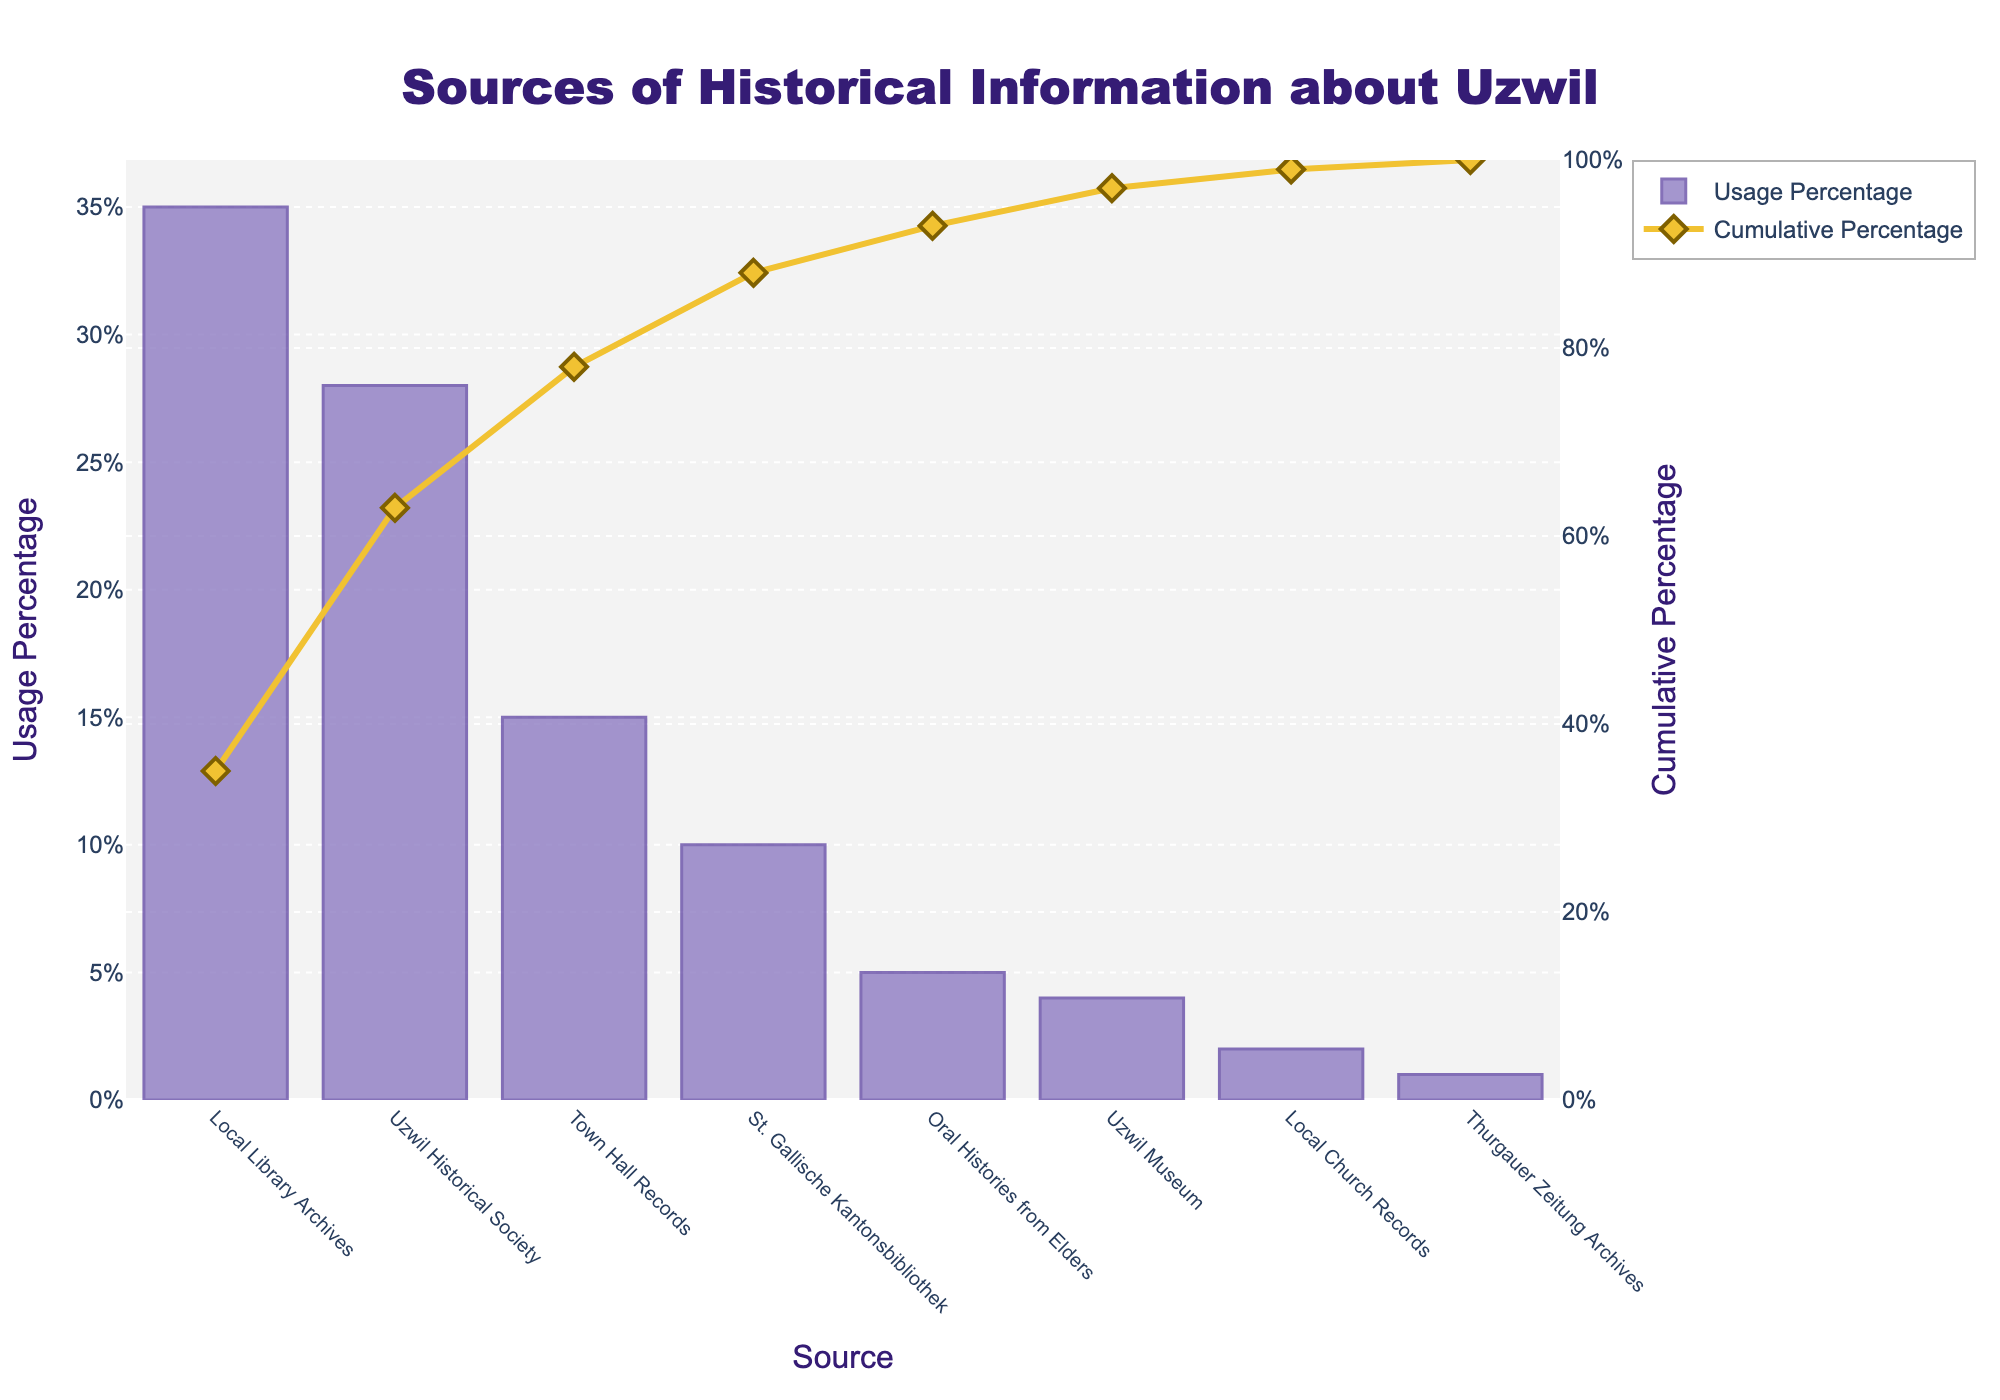What is the title of the Pareto chart? The title is positioned at the top-center of the plot in bold font. It provides an overview of what the chart is representing.
Answer: Sources of Historical Information about Uzwil Which source has the highest usage percentage? By inspecting the tallest bar on the Pareto chart, which represents the highest value.
Answer: Local Library Archives What's the cumulative percentage after looking at the top three sources? Summing the individual percentages for the top three sources: Local Library Archives (35%), Uzwil Historical Society (28%), and Town Hall Records (15%). The cumulative percentage for these three will be the sum, visible from the cumulative line.
Answer: 78% Which source is used the least among the residents? Identifying the label associated with the shortest bar in the chart.
Answer: Thurgauer Zeitung Archives How much more usage does the Uzwil Historical Society have compared to the St. Gallische Kantonsbibliothek? Subtracting the usage percentage of the St. Gallische Kantonsbibliothek (10%) from that of Uzwil Historical Society (28%).
Answer: 18% What is the difference in usage percentage between Oral Histories from Elders and Local Church Records? Subtracting the percentage of Local Church Records (2%) from Oral Histories from Elders (5%).
Answer: 3% At which source does the cumulative percentage reach more than 50%? Observing the cumulative percentage line to see where it first crosses the 50% mark, then noting the corresponding source.
Answer: Uzwil Historical Society How many sources have a usage percentage lower than 5? Counting the bars that reach up to 5% or less on the y-axis.
Answer: Three sources What are the colors used for the bars and the cumulative percentage line in the chart? Identifying the colors visually from the plot for both the bars and the line.
Answer: Bars: light purple; Cumulative percentage line: yellow Which source has a similar usage percentage as the St. Gallische Kantonsbibliothek? Comparing the height of the bars to find the one that has a usage percentage close to 10%, which corresponds to the St. Gallische Kantonsbibliothek.
Answer: Oral Histories from Elders 